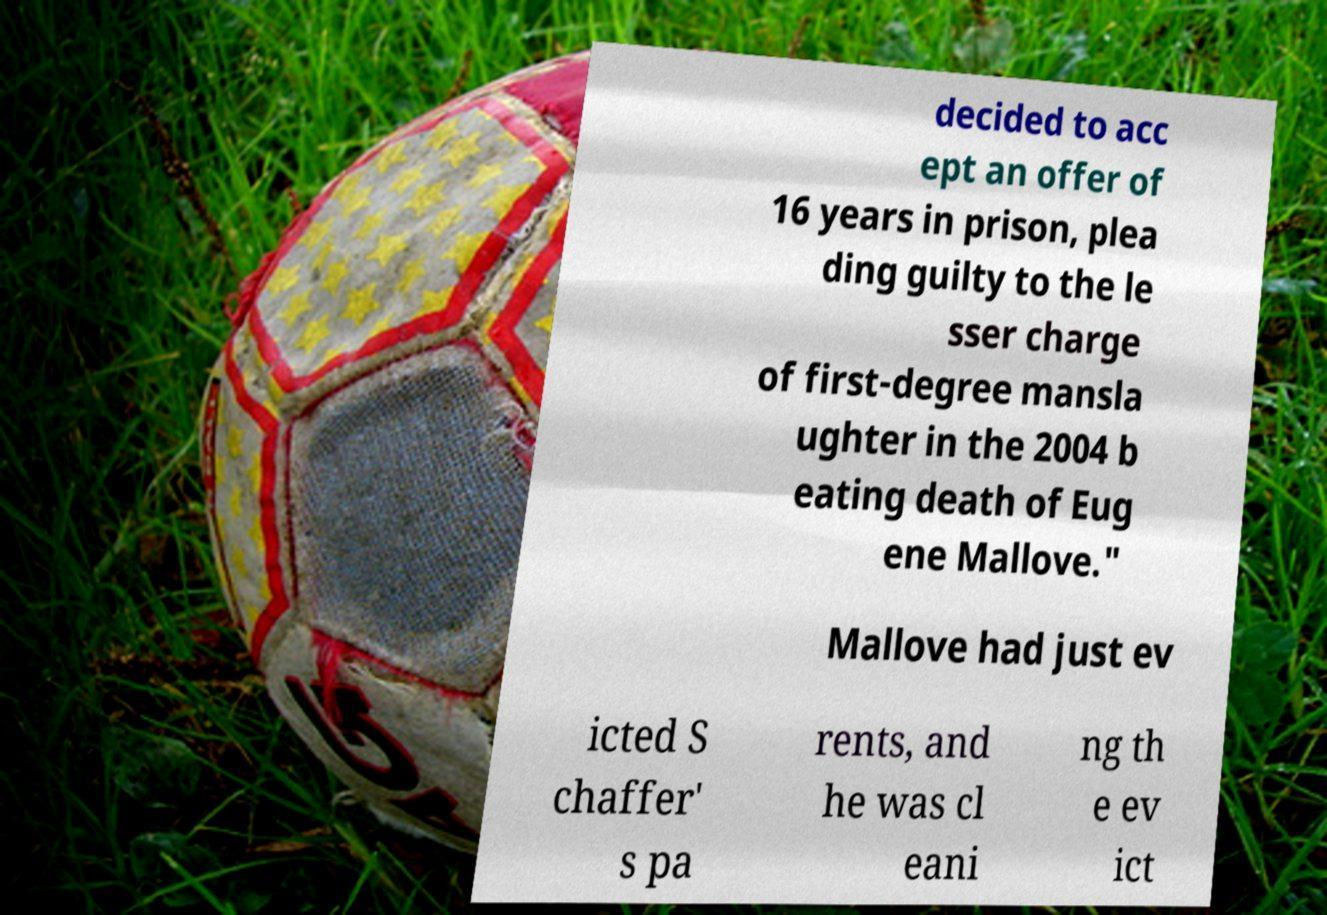There's text embedded in this image that I need extracted. Can you transcribe it verbatim? decided to acc ept an offer of 16 years in prison, plea ding guilty to the le sser charge of first-degree mansla ughter in the 2004 b eating death of Eug ene Mallove." Mallove had just ev icted S chaffer' s pa rents, and he was cl eani ng th e ev ict 